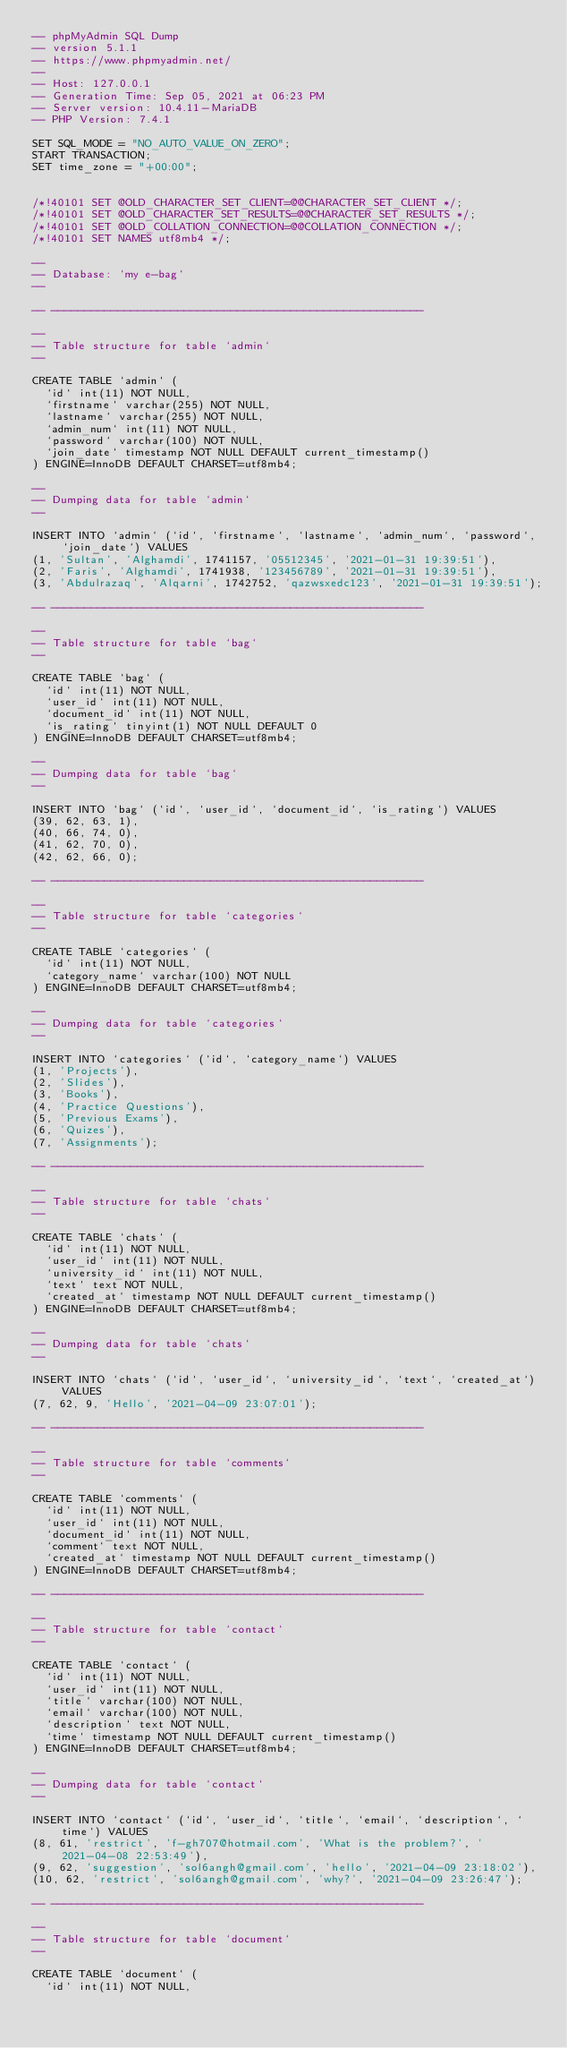<code> <loc_0><loc_0><loc_500><loc_500><_SQL_>-- phpMyAdmin SQL Dump
-- version 5.1.1
-- https://www.phpmyadmin.net/
--
-- Host: 127.0.0.1
-- Generation Time: Sep 05, 2021 at 06:23 PM
-- Server version: 10.4.11-MariaDB
-- PHP Version: 7.4.1

SET SQL_MODE = "NO_AUTO_VALUE_ON_ZERO";
START TRANSACTION;
SET time_zone = "+00:00";


/*!40101 SET @OLD_CHARACTER_SET_CLIENT=@@CHARACTER_SET_CLIENT */;
/*!40101 SET @OLD_CHARACTER_SET_RESULTS=@@CHARACTER_SET_RESULTS */;
/*!40101 SET @OLD_COLLATION_CONNECTION=@@COLLATION_CONNECTION */;
/*!40101 SET NAMES utf8mb4 */;

--
-- Database: `my e-bag`
--

-- --------------------------------------------------------

--
-- Table structure for table `admin`
--

CREATE TABLE `admin` (
  `id` int(11) NOT NULL,
  `firstname` varchar(255) NOT NULL,
  `lastname` varchar(255) NOT NULL,
  `admin_num` int(11) NOT NULL,
  `password` varchar(100) NOT NULL,
  `join_date` timestamp NOT NULL DEFAULT current_timestamp()
) ENGINE=InnoDB DEFAULT CHARSET=utf8mb4;

--
-- Dumping data for table `admin`
--

INSERT INTO `admin` (`id`, `firstname`, `lastname`, `admin_num`, `password`, `join_date`) VALUES
(1, 'Sultan', 'Alghamdi', 1741157, '05512345', '2021-01-31 19:39:51'),
(2, 'Faris', 'Alghamdi', 1741938, '123456789', '2021-01-31 19:39:51'),
(3, 'Abdulrazaq', 'Alqarni', 1742752, 'qazwsxedc123', '2021-01-31 19:39:51');

-- --------------------------------------------------------

--
-- Table structure for table `bag`
--

CREATE TABLE `bag` (
  `id` int(11) NOT NULL,
  `user_id` int(11) NOT NULL,
  `document_id` int(11) NOT NULL,
  `is_rating` tinyint(1) NOT NULL DEFAULT 0
) ENGINE=InnoDB DEFAULT CHARSET=utf8mb4;

--
-- Dumping data for table `bag`
--

INSERT INTO `bag` (`id`, `user_id`, `document_id`, `is_rating`) VALUES
(39, 62, 63, 1),
(40, 66, 74, 0),
(41, 62, 70, 0),
(42, 62, 66, 0);

-- --------------------------------------------------------

--
-- Table structure for table `categories`
--

CREATE TABLE `categories` (
  `id` int(11) NOT NULL,
  `category_name` varchar(100) NOT NULL
) ENGINE=InnoDB DEFAULT CHARSET=utf8mb4;

--
-- Dumping data for table `categories`
--

INSERT INTO `categories` (`id`, `category_name`) VALUES
(1, 'Projects'),
(2, 'Slides'),
(3, 'Books'),
(4, 'Practice Questions'),
(5, 'Previous Exams'),
(6, 'Quizes'),
(7, 'Assignments');

-- --------------------------------------------------------

--
-- Table structure for table `chats`
--

CREATE TABLE `chats` (
  `id` int(11) NOT NULL,
  `user_id` int(11) NOT NULL,
  `university_id` int(11) NOT NULL,
  `text` text NOT NULL,
  `created_at` timestamp NOT NULL DEFAULT current_timestamp()
) ENGINE=InnoDB DEFAULT CHARSET=utf8mb4;

--
-- Dumping data for table `chats`
--

INSERT INTO `chats` (`id`, `user_id`, `university_id`, `text`, `created_at`) VALUES
(7, 62, 9, 'Hello', '2021-04-09 23:07:01');

-- --------------------------------------------------------

--
-- Table structure for table `comments`
--

CREATE TABLE `comments` (
  `id` int(11) NOT NULL,
  `user_id` int(11) NOT NULL,
  `document_id` int(11) NOT NULL,
  `comment` text NOT NULL,
  `created_at` timestamp NOT NULL DEFAULT current_timestamp()
) ENGINE=InnoDB DEFAULT CHARSET=utf8mb4;

-- --------------------------------------------------------

--
-- Table structure for table `contact`
--

CREATE TABLE `contact` (
  `id` int(11) NOT NULL,
  `user_id` int(11) NOT NULL,
  `title` varchar(100) NOT NULL,
  `email` varchar(100) NOT NULL,
  `description` text NOT NULL,
  `time` timestamp NOT NULL DEFAULT current_timestamp()
) ENGINE=InnoDB DEFAULT CHARSET=utf8mb4;

--
-- Dumping data for table `contact`
--

INSERT INTO `contact` (`id`, `user_id`, `title`, `email`, `description`, `time`) VALUES
(8, 61, 'restrict', 'f-gh707@hotmail.com', 'What is the problem?', '2021-04-08 22:53:49'),
(9, 62, 'suggestion', 'sol6angh@gmail.com', 'hello', '2021-04-09 23:18:02'),
(10, 62, 'restrict', 'sol6angh@gmail.com', 'why?', '2021-04-09 23:26:47');

-- --------------------------------------------------------

--
-- Table structure for table `document`
--

CREATE TABLE `document` (
  `id` int(11) NOT NULL,</code> 